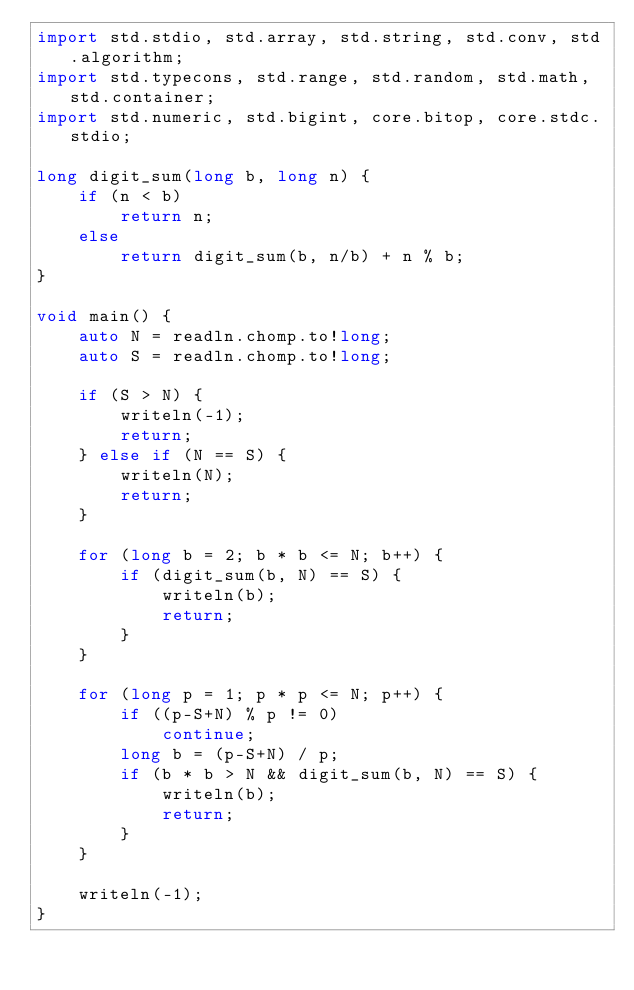<code> <loc_0><loc_0><loc_500><loc_500><_D_>import std.stdio, std.array, std.string, std.conv, std.algorithm;
import std.typecons, std.range, std.random, std.math, std.container;
import std.numeric, std.bigint, core.bitop, core.stdc.stdio;

long digit_sum(long b, long n) {
    if (n < b)
        return n;
    else
        return digit_sum(b, n/b) + n % b;
}

void main() {
    auto N = readln.chomp.to!long;
    auto S = readln.chomp.to!long;

    if (S > N) {
        writeln(-1);
        return;
    } else if (N == S) {
        writeln(N);
        return;
    }

    for (long b = 2; b * b <= N; b++) {
        if (digit_sum(b, N) == S) {
            writeln(b);
            return;
        }
    }

    for (long p = 1; p * p <= N; p++) {
        if ((p-S+N) % p != 0)
            continue;
        long b = (p-S+N) / p;
        if (b * b > N && digit_sum(b, N) == S) {
            writeln(b);
            return;
        }
    }

    writeln(-1);
}
</code> 